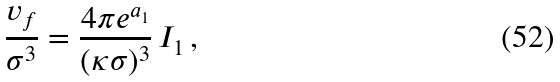<formula> <loc_0><loc_0><loc_500><loc_500>\frac { v _ { f } } { \sigma ^ { 3 } } = \frac { 4 \pi e ^ { a _ { 1 } } } { ( \kappa \sigma ) ^ { 3 } } \, I _ { 1 } \, ,</formula> 